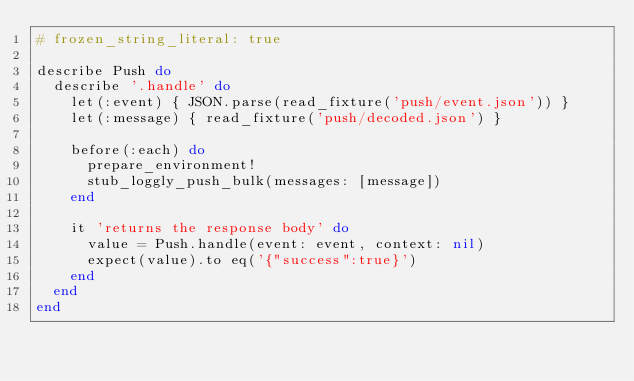<code> <loc_0><loc_0><loc_500><loc_500><_Ruby_># frozen_string_literal: true

describe Push do
  describe '.handle' do
    let(:event) { JSON.parse(read_fixture('push/event.json')) }
    let(:message) { read_fixture('push/decoded.json') }

    before(:each) do
      prepare_environment!
      stub_loggly_push_bulk(messages: [message])
    end

    it 'returns the response body' do
      value = Push.handle(event: event, context: nil)
      expect(value).to eq('{"success":true}')
    end
  end
end
</code> 